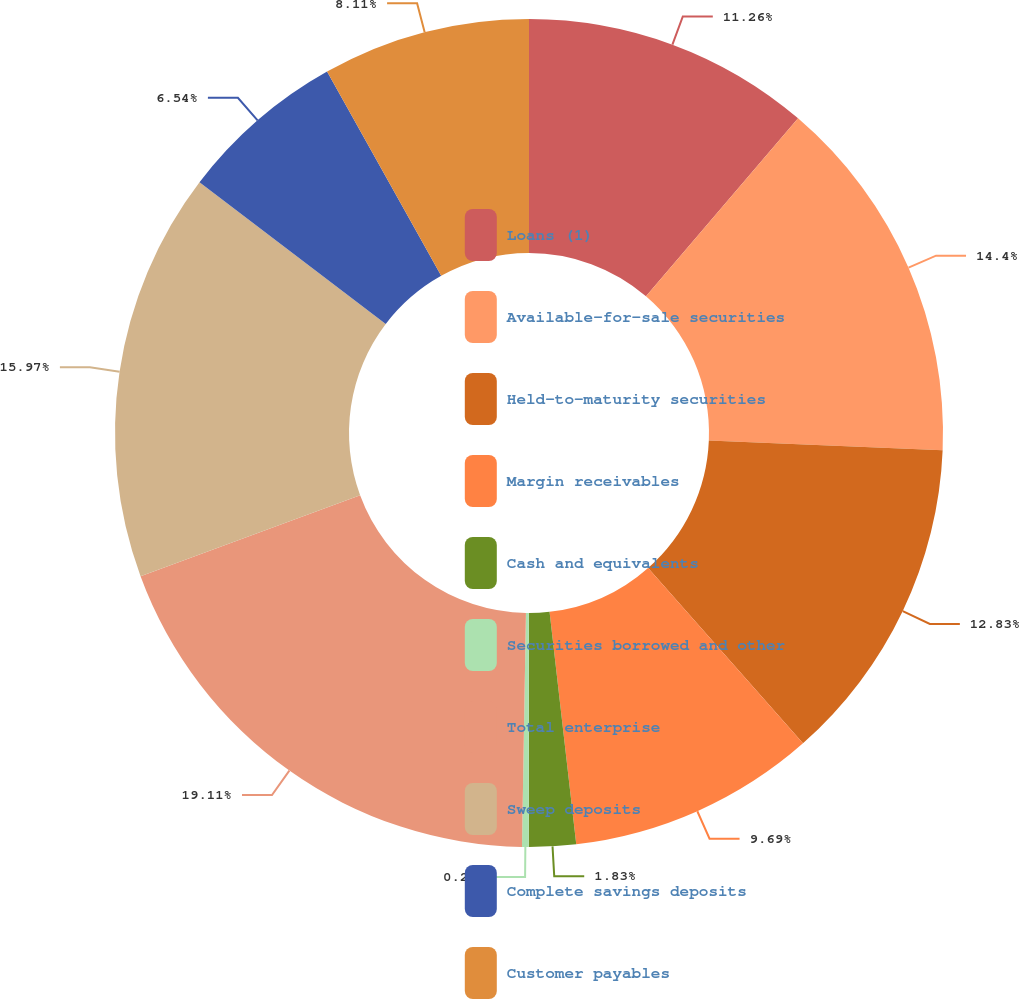Convert chart. <chart><loc_0><loc_0><loc_500><loc_500><pie_chart><fcel>Loans (1)<fcel>Available-for-sale securities<fcel>Held-to-maturity securities<fcel>Margin receivables<fcel>Cash and equivalents<fcel>Securities borrowed and other<fcel>Total enterprise<fcel>Sweep deposits<fcel>Complete savings deposits<fcel>Customer payables<nl><fcel>11.26%<fcel>14.4%<fcel>12.83%<fcel>9.69%<fcel>1.83%<fcel>0.26%<fcel>19.11%<fcel>15.97%<fcel>6.54%<fcel>8.11%<nl></chart> 